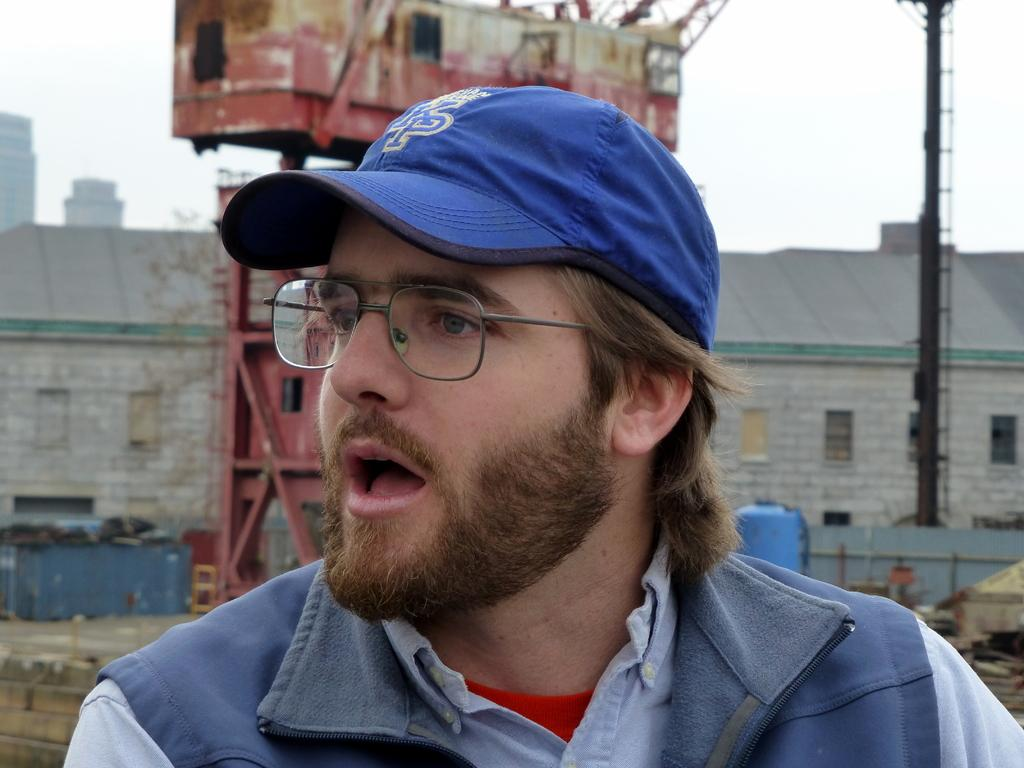What is the man in the image wearing on his head? The man in the image is wearing a cap. What can be seen in the background of the image? In the background of the image, there is a crane, an iron pole, buildings, a blue color object, and the sky. What type of structure is visible in the background? The crane and buildings in the background suggest an industrial or construction site. Can you see any ghosts in the image? There are no ghosts present in the image. What process is the man in the image performing? The image does not provide enough information to determine what process the man might be performing. 